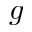<formula> <loc_0><loc_0><loc_500><loc_500>g</formula> 